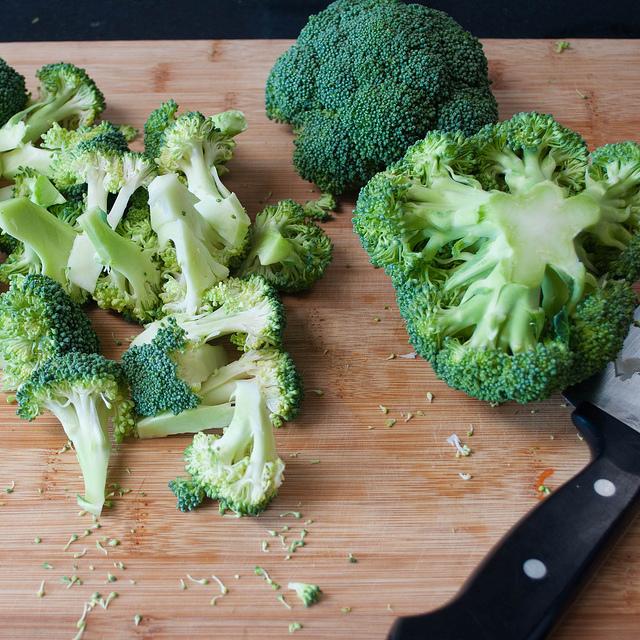What vegetable is this?
Answer briefly. Broccoli. How many rivets are on the handle?
Short answer required. 2. Is the veg on a cutting board?
Answer briefly. Yes. 